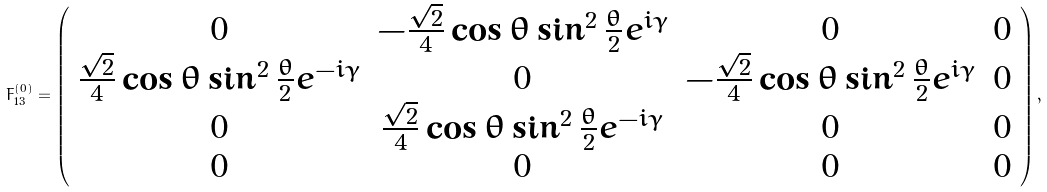<formula> <loc_0><loc_0><loc_500><loc_500>F ^ { ( 0 ) } _ { 1 3 } = \left ( \begin{array} { c c c c } 0 & - \frac { \sqrt { 2 } } { 4 } \cos \theta \sin ^ { 2 } \frac { \theta } { 2 } e ^ { i \gamma } & 0 & 0 \\ \frac { \sqrt { 2 } } { 4 } \cos \theta \sin ^ { 2 } \frac { \theta } { 2 } e ^ { - i \gamma } & 0 & - \frac { \sqrt { 2 } } { 4 } \cos \theta \sin ^ { 2 } \frac { \theta } { 2 } e ^ { i \gamma } & 0 \\ 0 & \frac { \sqrt { 2 } } { 4 } \cos \theta \sin ^ { 2 } \frac { \theta } { 2 } e ^ { - i \gamma } & 0 & 0 \\ 0 & 0 & 0 & 0 \end{array} \right ) ,</formula> 